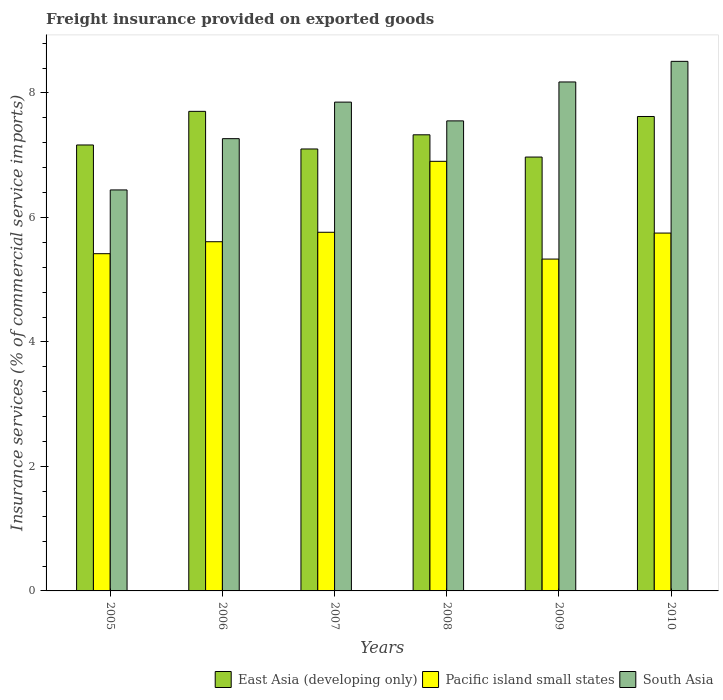How many groups of bars are there?
Provide a succinct answer. 6. Are the number of bars per tick equal to the number of legend labels?
Keep it short and to the point. Yes. Are the number of bars on each tick of the X-axis equal?
Your response must be concise. Yes. What is the freight insurance provided on exported goods in Pacific island small states in 2010?
Your response must be concise. 5.75. Across all years, what is the maximum freight insurance provided on exported goods in Pacific island small states?
Provide a short and direct response. 6.9. Across all years, what is the minimum freight insurance provided on exported goods in Pacific island small states?
Your response must be concise. 5.33. In which year was the freight insurance provided on exported goods in Pacific island small states maximum?
Your answer should be compact. 2008. What is the total freight insurance provided on exported goods in South Asia in the graph?
Your answer should be compact. 45.8. What is the difference between the freight insurance provided on exported goods in South Asia in 2005 and that in 2009?
Keep it short and to the point. -1.73. What is the difference between the freight insurance provided on exported goods in South Asia in 2007 and the freight insurance provided on exported goods in Pacific island small states in 2010?
Keep it short and to the point. 2.1. What is the average freight insurance provided on exported goods in Pacific island small states per year?
Provide a succinct answer. 5.8. In the year 2006, what is the difference between the freight insurance provided on exported goods in South Asia and freight insurance provided on exported goods in Pacific island small states?
Offer a very short reply. 1.66. In how many years, is the freight insurance provided on exported goods in East Asia (developing only) greater than 6 %?
Ensure brevity in your answer.  6. What is the ratio of the freight insurance provided on exported goods in East Asia (developing only) in 2006 to that in 2009?
Provide a short and direct response. 1.11. Is the freight insurance provided on exported goods in East Asia (developing only) in 2006 less than that in 2008?
Provide a short and direct response. No. What is the difference between the highest and the second highest freight insurance provided on exported goods in Pacific island small states?
Give a very brief answer. 1.14. What is the difference between the highest and the lowest freight insurance provided on exported goods in Pacific island small states?
Ensure brevity in your answer.  1.57. In how many years, is the freight insurance provided on exported goods in South Asia greater than the average freight insurance provided on exported goods in South Asia taken over all years?
Your answer should be very brief. 3. Is the sum of the freight insurance provided on exported goods in East Asia (developing only) in 2006 and 2007 greater than the maximum freight insurance provided on exported goods in Pacific island small states across all years?
Give a very brief answer. Yes. Is it the case that in every year, the sum of the freight insurance provided on exported goods in Pacific island small states and freight insurance provided on exported goods in East Asia (developing only) is greater than the freight insurance provided on exported goods in South Asia?
Offer a terse response. Yes. How many bars are there?
Your answer should be very brief. 18. Are all the bars in the graph horizontal?
Keep it short and to the point. No. Are the values on the major ticks of Y-axis written in scientific E-notation?
Keep it short and to the point. No. Does the graph contain any zero values?
Provide a short and direct response. No. Where does the legend appear in the graph?
Offer a terse response. Bottom right. How are the legend labels stacked?
Provide a succinct answer. Horizontal. What is the title of the graph?
Your answer should be very brief. Freight insurance provided on exported goods. Does "Low & middle income" appear as one of the legend labels in the graph?
Your answer should be compact. No. What is the label or title of the Y-axis?
Your answer should be very brief. Insurance services (% of commercial service imports). What is the Insurance services (% of commercial service imports) of East Asia (developing only) in 2005?
Give a very brief answer. 7.16. What is the Insurance services (% of commercial service imports) in Pacific island small states in 2005?
Ensure brevity in your answer.  5.42. What is the Insurance services (% of commercial service imports) in South Asia in 2005?
Your answer should be very brief. 6.44. What is the Insurance services (% of commercial service imports) of East Asia (developing only) in 2006?
Offer a very short reply. 7.7. What is the Insurance services (% of commercial service imports) of Pacific island small states in 2006?
Make the answer very short. 5.61. What is the Insurance services (% of commercial service imports) in South Asia in 2006?
Your response must be concise. 7.27. What is the Insurance services (% of commercial service imports) of East Asia (developing only) in 2007?
Offer a terse response. 7.1. What is the Insurance services (% of commercial service imports) in Pacific island small states in 2007?
Your answer should be compact. 5.76. What is the Insurance services (% of commercial service imports) in South Asia in 2007?
Give a very brief answer. 7.85. What is the Insurance services (% of commercial service imports) of East Asia (developing only) in 2008?
Provide a short and direct response. 7.33. What is the Insurance services (% of commercial service imports) in Pacific island small states in 2008?
Provide a succinct answer. 6.9. What is the Insurance services (% of commercial service imports) of South Asia in 2008?
Ensure brevity in your answer.  7.55. What is the Insurance services (% of commercial service imports) of East Asia (developing only) in 2009?
Your answer should be very brief. 6.97. What is the Insurance services (% of commercial service imports) of Pacific island small states in 2009?
Offer a very short reply. 5.33. What is the Insurance services (% of commercial service imports) of South Asia in 2009?
Give a very brief answer. 8.18. What is the Insurance services (% of commercial service imports) in East Asia (developing only) in 2010?
Your response must be concise. 7.62. What is the Insurance services (% of commercial service imports) in Pacific island small states in 2010?
Your response must be concise. 5.75. What is the Insurance services (% of commercial service imports) of South Asia in 2010?
Make the answer very short. 8.51. Across all years, what is the maximum Insurance services (% of commercial service imports) of East Asia (developing only)?
Your answer should be compact. 7.7. Across all years, what is the maximum Insurance services (% of commercial service imports) of Pacific island small states?
Ensure brevity in your answer.  6.9. Across all years, what is the maximum Insurance services (% of commercial service imports) in South Asia?
Give a very brief answer. 8.51. Across all years, what is the minimum Insurance services (% of commercial service imports) of East Asia (developing only)?
Offer a terse response. 6.97. Across all years, what is the minimum Insurance services (% of commercial service imports) of Pacific island small states?
Give a very brief answer. 5.33. Across all years, what is the minimum Insurance services (% of commercial service imports) in South Asia?
Your response must be concise. 6.44. What is the total Insurance services (% of commercial service imports) of East Asia (developing only) in the graph?
Your response must be concise. 43.89. What is the total Insurance services (% of commercial service imports) in Pacific island small states in the graph?
Provide a short and direct response. 34.77. What is the total Insurance services (% of commercial service imports) of South Asia in the graph?
Give a very brief answer. 45.8. What is the difference between the Insurance services (% of commercial service imports) of East Asia (developing only) in 2005 and that in 2006?
Offer a terse response. -0.54. What is the difference between the Insurance services (% of commercial service imports) in Pacific island small states in 2005 and that in 2006?
Your response must be concise. -0.19. What is the difference between the Insurance services (% of commercial service imports) in South Asia in 2005 and that in 2006?
Ensure brevity in your answer.  -0.82. What is the difference between the Insurance services (% of commercial service imports) in East Asia (developing only) in 2005 and that in 2007?
Your answer should be compact. 0.06. What is the difference between the Insurance services (% of commercial service imports) of Pacific island small states in 2005 and that in 2007?
Your answer should be compact. -0.34. What is the difference between the Insurance services (% of commercial service imports) of South Asia in 2005 and that in 2007?
Offer a very short reply. -1.41. What is the difference between the Insurance services (% of commercial service imports) of East Asia (developing only) in 2005 and that in 2008?
Provide a succinct answer. -0.16. What is the difference between the Insurance services (% of commercial service imports) in Pacific island small states in 2005 and that in 2008?
Offer a terse response. -1.48. What is the difference between the Insurance services (% of commercial service imports) of South Asia in 2005 and that in 2008?
Keep it short and to the point. -1.11. What is the difference between the Insurance services (% of commercial service imports) of East Asia (developing only) in 2005 and that in 2009?
Your answer should be compact. 0.19. What is the difference between the Insurance services (% of commercial service imports) in Pacific island small states in 2005 and that in 2009?
Keep it short and to the point. 0.09. What is the difference between the Insurance services (% of commercial service imports) of South Asia in 2005 and that in 2009?
Your response must be concise. -1.73. What is the difference between the Insurance services (% of commercial service imports) of East Asia (developing only) in 2005 and that in 2010?
Make the answer very short. -0.46. What is the difference between the Insurance services (% of commercial service imports) of Pacific island small states in 2005 and that in 2010?
Offer a very short reply. -0.33. What is the difference between the Insurance services (% of commercial service imports) of South Asia in 2005 and that in 2010?
Offer a terse response. -2.07. What is the difference between the Insurance services (% of commercial service imports) in East Asia (developing only) in 2006 and that in 2007?
Make the answer very short. 0.6. What is the difference between the Insurance services (% of commercial service imports) of Pacific island small states in 2006 and that in 2007?
Your answer should be very brief. -0.15. What is the difference between the Insurance services (% of commercial service imports) in South Asia in 2006 and that in 2007?
Keep it short and to the point. -0.59. What is the difference between the Insurance services (% of commercial service imports) of East Asia (developing only) in 2006 and that in 2008?
Give a very brief answer. 0.38. What is the difference between the Insurance services (% of commercial service imports) of Pacific island small states in 2006 and that in 2008?
Provide a succinct answer. -1.29. What is the difference between the Insurance services (% of commercial service imports) of South Asia in 2006 and that in 2008?
Provide a short and direct response. -0.29. What is the difference between the Insurance services (% of commercial service imports) of East Asia (developing only) in 2006 and that in 2009?
Keep it short and to the point. 0.73. What is the difference between the Insurance services (% of commercial service imports) in Pacific island small states in 2006 and that in 2009?
Your answer should be very brief. 0.28. What is the difference between the Insurance services (% of commercial service imports) of South Asia in 2006 and that in 2009?
Provide a succinct answer. -0.91. What is the difference between the Insurance services (% of commercial service imports) in East Asia (developing only) in 2006 and that in 2010?
Give a very brief answer. 0.08. What is the difference between the Insurance services (% of commercial service imports) of Pacific island small states in 2006 and that in 2010?
Ensure brevity in your answer.  -0.14. What is the difference between the Insurance services (% of commercial service imports) of South Asia in 2006 and that in 2010?
Your answer should be compact. -1.24. What is the difference between the Insurance services (% of commercial service imports) in East Asia (developing only) in 2007 and that in 2008?
Offer a terse response. -0.23. What is the difference between the Insurance services (% of commercial service imports) in Pacific island small states in 2007 and that in 2008?
Offer a very short reply. -1.14. What is the difference between the Insurance services (% of commercial service imports) in South Asia in 2007 and that in 2008?
Keep it short and to the point. 0.3. What is the difference between the Insurance services (% of commercial service imports) of East Asia (developing only) in 2007 and that in 2009?
Your response must be concise. 0.13. What is the difference between the Insurance services (% of commercial service imports) of Pacific island small states in 2007 and that in 2009?
Provide a short and direct response. 0.43. What is the difference between the Insurance services (% of commercial service imports) of South Asia in 2007 and that in 2009?
Make the answer very short. -0.32. What is the difference between the Insurance services (% of commercial service imports) of East Asia (developing only) in 2007 and that in 2010?
Make the answer very short. -0.52. What is the difference between the Insurance services (% of commercial service imports) of Pacific island small states in 2007 and that in 2010?
Offer a terse response. 0.01. What is the difference between the Insurance services (% of commercial service imports) in South Asia in 2007 and that in 2010?
Your response must be concise. -0.66. What is the difference between the Insurance services (% of commercial service imports) of East Asia (developing only) in 2008 and that in 2009?
Ensure brevity in your answer.  0.36. What is the difference between the Insurance services (% of commercial service imports) in Pacific island small states in 2008 and that in 2009?
Provide a short and direct response. 1.57. What is the difference between the Insurance services (% of commercial service imports) of South Asia in 2008 and that in 2009?
Offer a very short reply. -0.63. What is the difference between the Insurance services (% of commercial service imports) in East Asia (developing only) in 2008 and that in 2010?
Your answer should be compact. -0.29. What is the difference between the Insurance services (% of commercial service imports) of Pacific island small states in 2008 and that in 2010?
Offer a terse response. 1.15. What is the difference between the Insurance services (% of commercial service imports) of South Asia in 2008 and that in 2010?
Make the answer very short. -0.96. What is the difference between the Insurance services (% of commercial service imports) in East Asia (developing only) in 2009 and that in 2010?
Keep it short and to the point. -0.65. What is the difference between the Insurance services (% of commercial service imports) in Pacific island small states in 2009 and that in 2010?
Your response must be concise. -0.42. What is the difference between the Insurance services (% of commercial service imports) in South Asia in 2009 and that in 2010?
Your answer should be compact. -0.33. What is the difference between the Insurance services (% of commercial service imports) of East Asia (developing only) in 2005 and the Insurance services (% of commercial service imports) of Pacific island small states in 2006?
Your response must be concise. 1.55. What is the difference between the Insurance services (% of commercial service imports) of East Asia (developing only) in 2005 and the Insurance services (% of commercial service imports) of South Asia in 2006?
Keep it short and to the point. -0.1. What is the difference between the Insurance services (% of commercial service imports) in Pacific island small states in 2005 and the Insurance services (% of commercial service imports) in South Asia in 2006?
Ensure brevity in your answer.  -1.85. What is the difference between the Insurance services (% of commercial service imports) in East Asia (developing only) in 2005 and the Insurance services (% of commercial service imports) in Pacific island small states in 2007?
Make the answer very short. 1.4. What is the difference between the Insurance services (% of commercial service imports) in East Asia (developing only) in 2005 and the Insurance services (% of commercial service imports) in South Asia in 2007?
Ensure brevity in your answer.  -0.69. What is the difference between the Insurance services (% of commercial service imports) in Pacific island small states in 2005 and the Insurance services (% of commercial service imports) in South Asia in 2007?
Provide a short and direct response. -2.44. What is the difference between the Insurance services (% of commercial service imports) of East Asia (developing only) in 2005 and the Insurance services (% of commercial service imports) of Pacific island small states in 2008?
Provide a short and direct response. 0.26. What is the difference between the Insurance services (% of commercial service imports) of East Asia (developing only) in 2005 and the Insurance services (% of commercial service imports) of South Asia in 2008?
Provide a short and direct response. -0.39. What is the difference between the Insurance services (% of commercial service imports) in Pacific island small states in 2005 and the Insurance services (% of commercial service imports) in South Asia in 2008?
Offer a terse response. -2.13. What is the difference between the Insurance services (% of commercial service imports) of East Asia (developing only) in 2005 and the Insurance services (% of commercial service imports) of Pacific island small states in 2009?
Offer a very short reply. 1.83. What is the difference between the Insurance services (% of commercial service imports) in East Asia (developing only) in 2005 and the Insurance services (% of commercial service imports) in South Asia in 2009?
Offer a very short reply. -1.01. What is the difference between the Insurance services (% of commercial service imports) in Pacific island small states in 2005 and the Insurance services (% of commercial service imports) in South Asia in 2009?
Offer a terse response. -2.76. What is the difference between the Insurance services (% of commercial service imports) of East Asia (developing only) in 2005 and the Insurance services (% of commercial service imports) of Pacific island small states in 2010?
Make the answer very short. 1.42. What is the difference between the Insurance services (% of commercial service imports) of East Asia (developing only) in 2005 and the Insurance services (% of commercial service imports) of South Asia in 2010?
Make the answer very short. -1.34. What is the difference between the Insurance services (% of commercial service imports) of Pacific island small states in 2005 and the Insurance services (% of commercial service imports) of South Asia in 2010?
Make the answer very short. -3.09. What is the difference between the Insurance services (% of commercial service imports) of East Asia (developing only) in 2006 and the Insurance services (% of commercial service imports) of Pacific island small states in 2007?
Give a very brief answer. 1.94. What is the difference between the Insurance services (% of commercial service imports) in East Asia (developing only) in 2006 and the Insurance services (% of commercial service imports) in South Asia in 2007?
Give a very brief answer. -0.15. What is the difference between the Insurance services (% of commercial service imports) of Pacific island small states in 2006 and the Insurance services (% of commercial service imports) of South Asia in 2007?
Make the answer very short. -2.24. What is the difference between the Insurance services (% of commercial service imports) in East Asia (developing only) in 2006 and the Insurance services (% of commercial service imports) in Pacific island small states in 2008?
Provide a short and direct response. 0.8. What is the difference between the Insurance services (% of commercial service imports) in East Asia (developing only) in 2006 and the Insurance services (% of commercial service imports) in South Asia in 2008?
Make the answer very short. 0.15. What is the difference between the Insurance services (% of commercial service imports) in Pacific island small states in 2006 and the Insurance services (% of commercial service imports) in South Asia in 2008?
Keep it short and to the point. -1.94. What is the difference between the Insurance services (% of commercial service imports) in East Asia (developing only) in 2006 and the Insurance services (% of commercial service imports) in Pacific island small states in 2009?
Provide a short and direct response. 2.37. What is the difference between the Insurance services (% of commercial service imports) of East Asia (developing only) in 2006 and the Insurance services (% of commercial service imports) of South Asia in 2009?
Your answer should be very brief. -0.47. What is the difference between the Insurance services (% of commercial service imports) in Pacific island small states in 2006 and the Insurance services (% of commercial service imports) in South Asia in 2009?
Your answer should be compact. -2.57. What is the difference between the Insurance services (% of commercial service imports) of East Asia (developing only) in 2006 and the Insurance services (% of commercial service imports) of Pacific island small states in 2010?
Provide a short and direct response. 1.96. What is the difference between the Insurance services (% of commercial service imports) in East Asia (developing only) in 2006 and the Insurance services (% of commercial service imports) in South Asia in 2010?
Make the answer very short. -0.8. What is the difference between the Insurance services (% of commercial service imports) of Pacific island small states in 2006 and the Insurance services (% of commercial service imports) of South Asia in 2010?
Keep it short and to the point. -2.9. What is the difference between the Insurance services (% of commercial service imports) of East Asia (developing only) in 2007 and the Insurance services (% of commercial service imports) of Pacific island small states in 2008?
Provide a short and direct response. 0.2. What is the difference between the Insurance services (% of commercial service imports) of East Asia (developing only) in 2007 and the Insurance services (% of commercial service imports) of South Asia in 2008?
Make the answer very short. -0.45. What is the difference between the Insurance services (% of commercial service imports) in Pacific island small states in 2007 and the Insurance services (% of commercial service imports) in South Asia in 2008?
Your response must be concise. -1.79. What is the difference between the Insurance services (% of commercial service imports) in East Asia (developing only) in 2007 and the Insurance services (% of commercial service imports) in Pacific island small states in 2009?
Offer a terse response. 1.77. What is the difference between the Insurance services (% of commercial service imports) of East Asia (developing only) in 2007 and the Insurance services (% of commercial service imports) of South Asia in 2009?
Offer a terse response. -1.08. What is the difference between the Insurance services (% of commercial service imports) in Pacific island small states in 2007 and the Insurance services (% of commercial service imports) in South Asia in 2009?
Offer a terse response. -2.41. What is the difference between the Insurance services (% of commercial service imports) in East Asia (developing only) in 2007 and the Insurance services (% of commercial service imports) in Pacific island small states in 2010?
Your answer should be compact. 1.35. What is the difference between the Insurance services (% of commercial service imports) of East Asia (developing only) in 2007 and the Insurance services (% of commercial service imports) of South Asia in 2010?
Your response must be concise. -1.41. What is the difference between the Insurance services (% of commercial service imports) in Pacific island small states in 2007 and the Insurance services (% of commercial service imports) in South Asia in 2010?
Make the answer very short. -2.75. What is the difference between the Insurance services (% of commercial service imports) in East Asia (developing only) in 2008 and the Insurance services (% of commercial service imports) in Pacific island small states in 2009?
Your answer should be compact. 2. What is the difference between the Insurance services (% of commercial service imports) in East Asia (developing only) in 2008 and the Insurance services (% of commercial service imports) in South Asia in 2009?
Give a very brief answer. -0.85. What is the difference between the Insurance services (% of commercial service imports) of Pacific island small states in 2008 and the Insurance services (% of commercial service imports) of South Asia in 2009?
Provide a succinct answer. -1.27. What is the difference between the Insurance services (% of commercial service imports) in East Asia (developing only) in 2008 and the Insurance services (% of commercial service imports) in Pacific island small states in 2010?
Offer a very short reply. 1.58. What is the difference between the Insurance services (% of commercial service imports) in East Asia (developing only) in 2008 and the Insurance services (% of commercial service imports) in South Asia in 2010?
Offer a terse response. -1.18. What is the difference between the Insurance services (% of commercial service imports) in Pacific island small states in 2008 and the Insurance services (% of commercial service imports) in South Asia in 2010?
Provide a short and direct response. -1.61. What is the difference between the Insurance services (% of commercial service imports) in East Asia (developing only) in 2009 and the Insurance services (% of commercial service imports) in Pacific island small states in 2010?
Ensure brevity in your answer.  1.22. What is the difference between the Insurance services (% of commercial service imports) in East Asia (developing only) in 2009 and the Insurance services (% of commercial service imports) in South Asia in 2010?
Your response must be concise. -1.54. What is the difference between the Insurance services (% of commercial service imports) of Pacific island small states in 2009 and the Insurance services (% of commercial service imports) of South Asia in 2010?
Offer a terse response. -3.18. What is the average Insurance services (% of commercial service imports) of East Asia (developing only) per year?
Provide a short and direct response. 7.31. What is the average Insurance services (% of commercial service imports) of Pacific island small states per year?
Give a very brief answer. 5.8. What is the average Insurance services (% of commercial service imports) in South Asia per year?
Make the answer very short. 7.63. In the year 2005, what is the difference between the Insurance services (% of commercial service imports) in East Asia (developing only) and Insurance services (% of commercial service imports) in Pacific island small states?
Your answer should be compact. 1.75. In the year 2005, what is the difference between the Insurance services (% of commercial service imports) in East Asia (developing only) and Insurance services (% of commercial service imports) in South Asia?
Keep it short and to the point. 0.72. In the year 2005, what is the difference between the Insurance services (% of commercial service imports) in Pacific island small states and Insurance services (% of commercial service imports) in South Asia?
Your answer should be very brief. -1.02. In the year 2006, what is the difference between the Insurance services (% of commercial service imports) of East Asia (developing only) and Insurance services (% of commercial service imports) of Pacific island small states?
Your answer should be compact. 2.09. In the year 2006, what is the difference between the Insurance services (% of commercial service imports) of East Asia (developing only) and Insurance services (% of commercial service imports) of South Asia?
Your answer should be compact. 0.44. In the year 2006, what is the difference between the Insurance services (% of commercial service imports) in Pacific island small states and Insurance services (% of commercial service imports) in South Asia?
Provide a short and direct response. -1.66. In the year 2007, what is the difference between the Insurance services (% of commercial service imports) of East Asia (developing only) and Insurance services (% of commercial service imports) of Pacific island small states?
Your answer should be compact. 1.34. In the year 2007, what is the difference between the Insurance services (% of commercial service imports) of East Asia (developing only) and Insurance services (% of commercial service imports) of South Asia?
Offer a terse response. -0.75. In the year 2007, what is the difference between the Insurance services (% of commercial service imports) in Pacific island small states and Insurance services (% of commercial service imports) in South Asia?
Keep it short and to the point. -2.09. In the year 2008, what is the difference between the Insurance services (% of commercial service imports) in East Asia (developing only) and Insurance services (% of commercial service imports) in Pacific island small states?
Your response must be concise. 0.43. In the year 2008, what is the difference between the Insurance services (% of commercial service imports) in East Asia (developing only) and Insurance services (% of commercial service imports) in South Asia?
Offer a terse response. -0.22. In the year 2008, what is the difference between the Insurance services (% of commercial service imports) of Pacific island small states and Insurance services (% of commercial service imports) of South Asia?
Your response must be concise. -0.65. In the year 2009, what is the difference between the Insurance services (% of commercial service imports) of East Asia (developing only) and Insurance services (% of commercial service imports) of Pacific island small states?
Make the answer very short. 1.64. In the year 2009, what is the difference between the Insurance services (% of commercial service imports) of East Asia (developing only) and Insurance services (% of commercial service imports) of South Asia?
Provide a succinct answer. -1.21. In the year 2009, what is the difference between the Insurance services (% of commercial service imports) in Pacific island small states and Insurance services (% of commercial service imports) in South Asia?
Offer a terse response. -2.85. In the year 2010, what is the difference between the Insurance services (% of commercial service imports) in East Asia (developing only) and Insurance services (% of commercial service imports) in Pacific island small states?
Offer a terse response. 1.87. In the year 2010, what is the difference between the Insurance services (% of commercial service imports) of East Asia (developing only) and Insurance services (% of commercial service imports) of South Asia?
Keep it short and to the point. -0.89. In the year 2010, what is the difference between the Insurance services (% of commercial service imports) in Pacific island small states and Insurance services (% of commercial service imports) in South Asia?
Your response must be concise. -2.76. What is the ratio of the Insurance services (% of commercial service imports) of East Asia (developing only) in 2005 to that in 2006?
Offer a very short reply. 0.93. What is the ratio of the Insurance services (% of commercial service imports) in Pacific island small states in 2005 to that in 2006?
Ensure brevity in your answer.  0.97. What is the ratio of the Insurance services (% of commercial service imports) of South Asia in 2005 to that in 2006?
Provide a short and direct response. 0.89. What is the ratio of the Insurance services (% of commercial service imports) in East Asia (developing only) in 2005 to that in 2007?
Your response must be concise. 1.01. What is the ratio of the Insurance services (% of commercial service imports) of Pacific island small states in 2005 to that in 2007?
Provide a succinct answer. 0.94. What is the ratio of the Insurance services (% of commercial service imports) in South Asia in 2005 to that in 2007?
Your response must be concise. 0.82. What is the ratio of the Insurance services (% of commercial service imports) in East Asia (developing only) in 2005 to that in 2008?
Provide a short and direct response. 0.98. What is the ratio of the Insurance services (% of commercial service imports) in Pacific island small states in 2005 to that in 2008?
Ensure brevity in your answer.  0.79. What is the ratio of the Insurance services (% of commercial service imports) of South Asia in 2005 to that in 2008?
Offer a very short reply. 0.85. What is the ratio of the Insurance services (% of commercial service imports) of East Asia (developing only) in 2005 to that in 2009?
Make the answer very short. 1.03. What is the ratio of the Insurance services (% of commercial service imports) in Pacific island small states in 2005 to that in 2009?
Offer a very short reply. 1.02. What is the ratio of the Insurance services (% of commercial service imports) in South Asia in 2005 to that in 2009?
Your answer should be compact. 0.79. What is the ratio of the Insurance services (% of commercial service imports) in East Asia (developing only) in 2005 to that in 2010?
Provide a succinct answer. 0.94. What is the ratio of the Insurance services (% of commercial service imports) of Pacific island small states in 2005 to that in 2010?
Provide a short and direct response. 0.94. What is the ratio of the Insurance services (% of commercial service imports) of South Asia in 2005 to that in 2010?
Offer a terse response. 0.76. What is the ratio of the Insurance services (% of commercial service imports) of East Asia (developing only) in 2006 to that in 2007?
Your answer should be compact. 1.09. What is the ratio of the Insurance services (% of commercial service imports) in Pacific island small states in 2006 to that in 2007?
Give a very brief answer. 0.97. What is the ratio of the Insurance services (% of commercial service imports) of South Asia in 2006 to that in 2007?
Give a very brief answer. 0.93. What is the ratio of the Insurance services (% of commercial service imports) of East Asia (developing only) in 2006 to that in 2008?
Make the answer very short. 1.05. What is the ratio of the Insurance services (% of commercial service imports) in Pacific island small states in 2006 to that in 2008?
Your response must be concise. 0.81. What is the ratio of the Insurance services (% of commercial service imports) in South Asia in 2006 to that in 2008?
Your response must be concise. 0.96. What is the ratio of the Insurance services (% of commercial service imports) of East Asia (developing only) in 2006 to that in 2009?
Provide a short and direct response. 1.11. What is the ratio of the Insurance services (% of commercial service imports) of Pacific island small states in 2006 to that in 2009?
Provide a short and direct response. 1.05. What is the ratio of the Insurance services (% of commercial service imports) in South Asia in 2006 to that in 2009?
Your answer should be compact. 0.89. What is the ratio of the Insurance services (% of commercial service imports) in East Asia (developing only) in 2006 to that in 2010?
Your response must be concise. 1.01. What is the ratio of the Insurance services (% of commercial service imports) in Pacific island small states in 2006 to that in 2010?
Offer a very short reply. 0.98. What is the ratio of the Insurance services (% of commercial service imports) in South Asia in 2006 to that in 2010?
Offer a terse response. 0.85. What is the ratio of the Insurance services (% of commercial service imports) in East Asia (developing only) in 2007 to that in 2008?
Your answer should be very brief. 0.97. What is the ratio of the Insurance services (% of commercial service imports) in Pacific island small states in 2007 to that in 2008?
Provide a succinct answer. 0.83. What is the ratio of the Insurance services (% of commercial service imports) of South Asia in 2007 to that in 2008?
Offer a very short reply. 1.04. What is the ratio of the Insurance services (% of commercial service imports) of East Asia (developing only) in 2007 to that in 2009?
Offer a terse response. 1.02. What is the ratio of the Insurance services (% of commercial service imports) of Pacific island small states in 2007 to that in 2009?
Your answer should be very brief. 1.08. What is the ratio of the Insurance services (% of commercial service imports) of South Asia in 2007 to that in 2009?
Give a very brief answer. 0.96. What is the ratio of the Insurance services (% of commercial service imports) of East Asia (developing only) in 2007 to that in 2010?
Ensure brevity in your answer.  0.93. What is the ratio of the Insurance services (% of commercial service imports) of South Asia in 2007 to that in 2010?
Your answer should be very brief. 0.92. What is the ratio of the Insurance services (% of commercial service imports) in East Asia (developing only) in 2008 to that in 2009?
Your response must be concise. 1.05. What is the ratio of the Insurance services (% of commercial service imports) in Pacific island small states in 2008 to that in 2009?
Your answer should be very brief. 1.29. What is the ratio of the Insurance services (% of commercial service imports) of South Asia in 2008 to that in 2009?
Offer a terse response. 0.92. What is the ratio of the Insurance services (% of commercial service imports) in East Asia (developing only) in 2008 to that in 2010?
Your answer should be very brief. 0.96. What is the ratio of the Insurance services (% of commercial service imports) in Pacific island small states in 2008 to that in 2010?
Give a very brief answer. 1.2. What is the ratio of the Insurance services (% of commercial service imports) in South Asia in 2008 to that in 2010?
Keep it short and to the point. 0.89. What is the ratio of the Insurance services (% of commercial service imports) of East Asia (developing only) in 2009 to that in 2010?
Offer a terse response. 0.91. What is the ratio of the Insurance services (% of commercial service imports) of Pacific island small states in 2009 to that in 2010?
Your response must be concise. 0.93. What is the ratio of the Insurance services (% of commercial service imports) in South Asia in 2009 to that in 2010?
Offer a terse response. 0.96. What is the difference between the highest and the second highest Insurance services (% of commercial service imports) in East Asia (developing only)?
Make the answer very short. 0.08. What is the difference between the highest and the second highest Insurance services (% of commercial service imports) in Pacific island small states?
Make the answer very short. 1.14. What is the difference between the highest and the second highest Insurance services (% of commercial service imports) of South Asia?
Your response must be concise. 0.33. What is the difference between the highest and the lowest Insurance services (% of commercial service imports) in East Asia (developing only)?
Provide a succinct answer. 0.73. What is the difference between the highest and the lowest Insurance services (% of commercial service imports) in Pacific island small states?
Offer a terse response. 1.57. What is the difference between the highest and the lowest Insurance services (% of commercial service imports) in South Asia?
Your response must be concise. 2.07. 